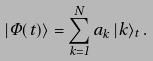<formula> <loc_0><loc_0><loc_500><loc_500>| { \Phi } ( t ) \rangle = \sum _ { k = 1 } ^ { N } a _ { k } \, | k \rangle _ { t } \, .</formula> 